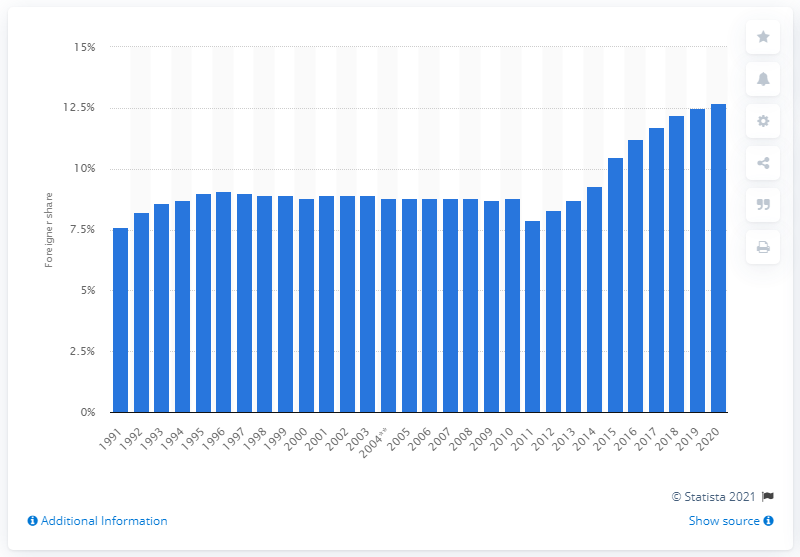Highlight a few significant elements in this photo. In 2020, the percentage of foreigners in Germany was 12.7%. 